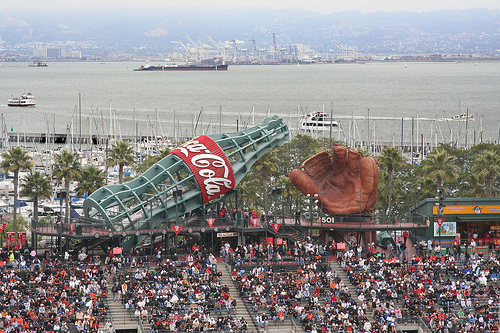<image>
Is the crowd behind the bottle? No. The crowd is not behind the bottle. From this viewpoint, the crowd appears to be positioned elsewhere in the scene. Where is the ocean in relation to the bottle? Is it on the bottle? No. The ocean is not positioned on the bottle. They may be near each other, but the ocean is not supported by or resting on top of the bottle. 